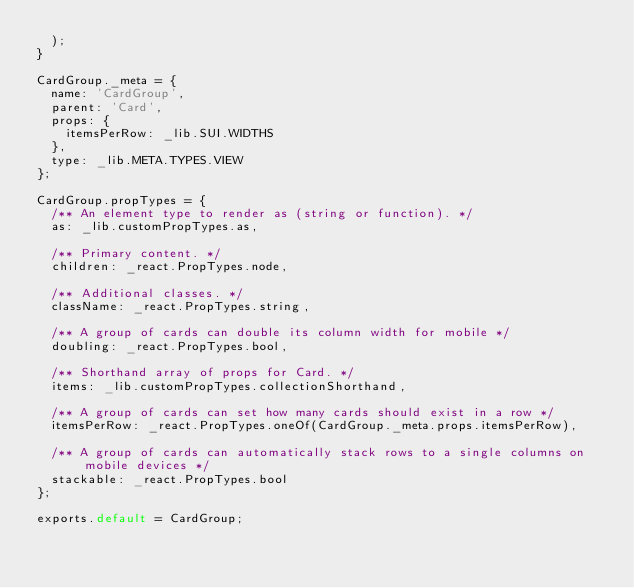Convert code to text. <code><loc_0><loc_0><loc_500><loc_500><_JavaScript_>  );
}

CardGroup._meta = {
  name: 'CardGroup',
  parent: 'Card',
  props: {
    itemsPerRow: _lib.SUI.WIDTHS
  },
  type: _lib.META.TYPES.VIEW
};

CardGroup.propTypes = {
  /** An element type to render as (string or function). */
  as: _lib.customPropTypes.as,

  /** Primary content. */
  children: _react.PropTypes.node,

  /** Additional classes. */
  className: _react.PropTypes.string,

  /** A group of cards can double its column width for mobile */
  doubling: _react.PropTypes.bool,

  /** Shorthand array of props for Card. */
  items: _lib.customPropTypes.collectionShorthand,

  /** A group of cards can set how many cards should exist in a row */
  itemsPerRow: _react.PropTypes.oneOf(CardGroup._meta.props.itemsPerRow),

  /** A group of cards can automatically stack rows to a single columns on mobile devices */
  stackable: _react.PropTypes.bool
};

exports.default = CardGroup;</code> 